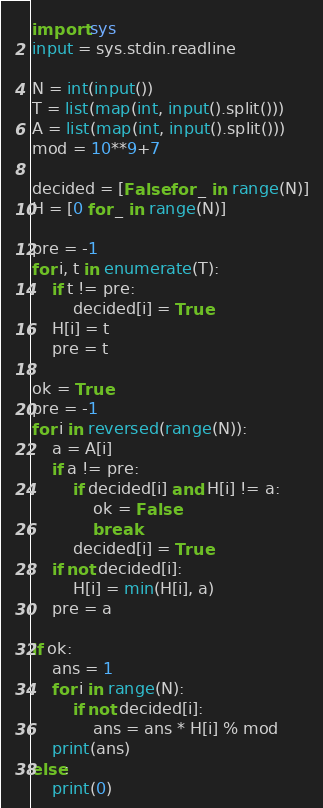Convert code to text. <code><loc_0><loc_0><loc_500><loc_500><_Python_>import sys
input = sys.stdin.readline

N = int(input())
T = list(map(int, input().split()))
A = list(map(int, input().split()))
mod = 10**9+7

decided = [False for _ in range(N)]
H = [0 for _ in range(N)]

pre = -1
for i, t in enumerate(T):
    if t != pre:
        decided[i] = True
    H[i] = t
    pre = t

ok = True
pre = -1
for i in reversed(range(N)):
    a = A[i]
    if a != pre:
        if decided[i] and H[i] != a:
            ok = False
            break
        decided[i] = True
    if not decided[i]:
        H[i] = min(H[i], a)
    pre = a

if ok:
    ans = 1
    for i in range(N):
        if not decided[i]:
            ans = ans * H[i] % mod
    print(ans)
else:
    print(0)</code> 